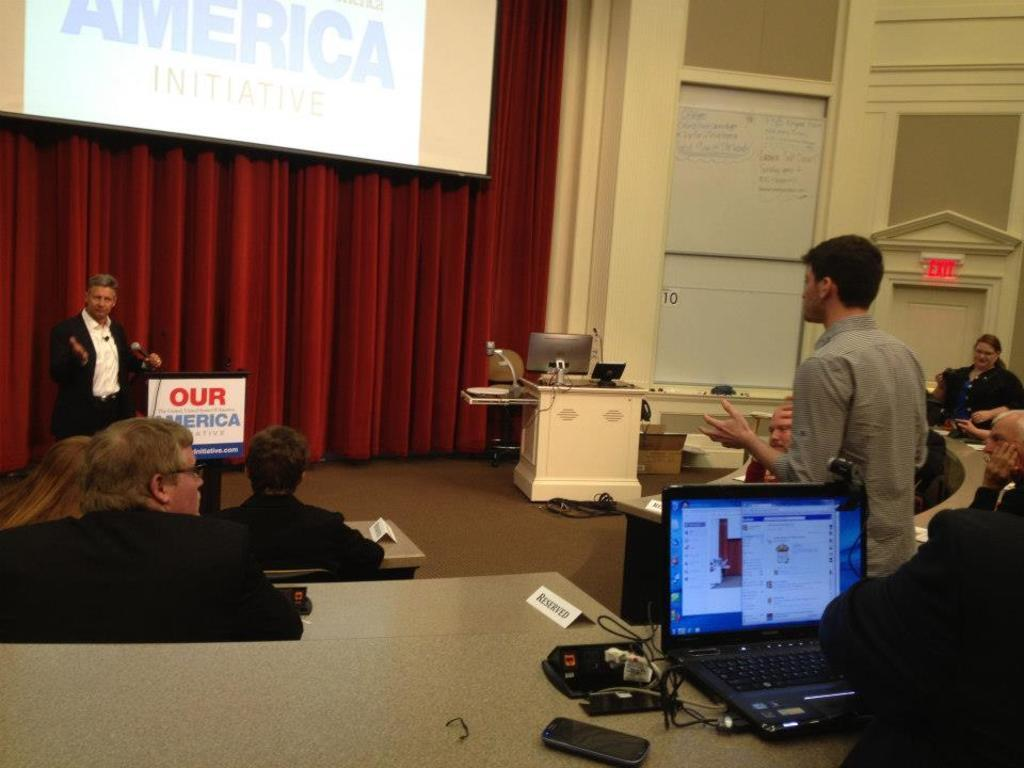<image>
Summarize the visual content of the image. A person is speaking with students at an Our America presentation. 